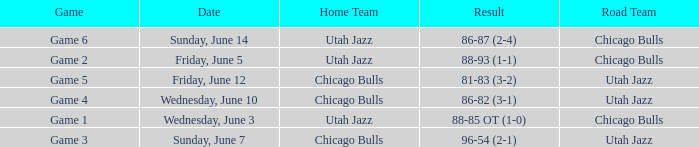Result of 88-85 ot (1-0) involves what game? Game 1. 